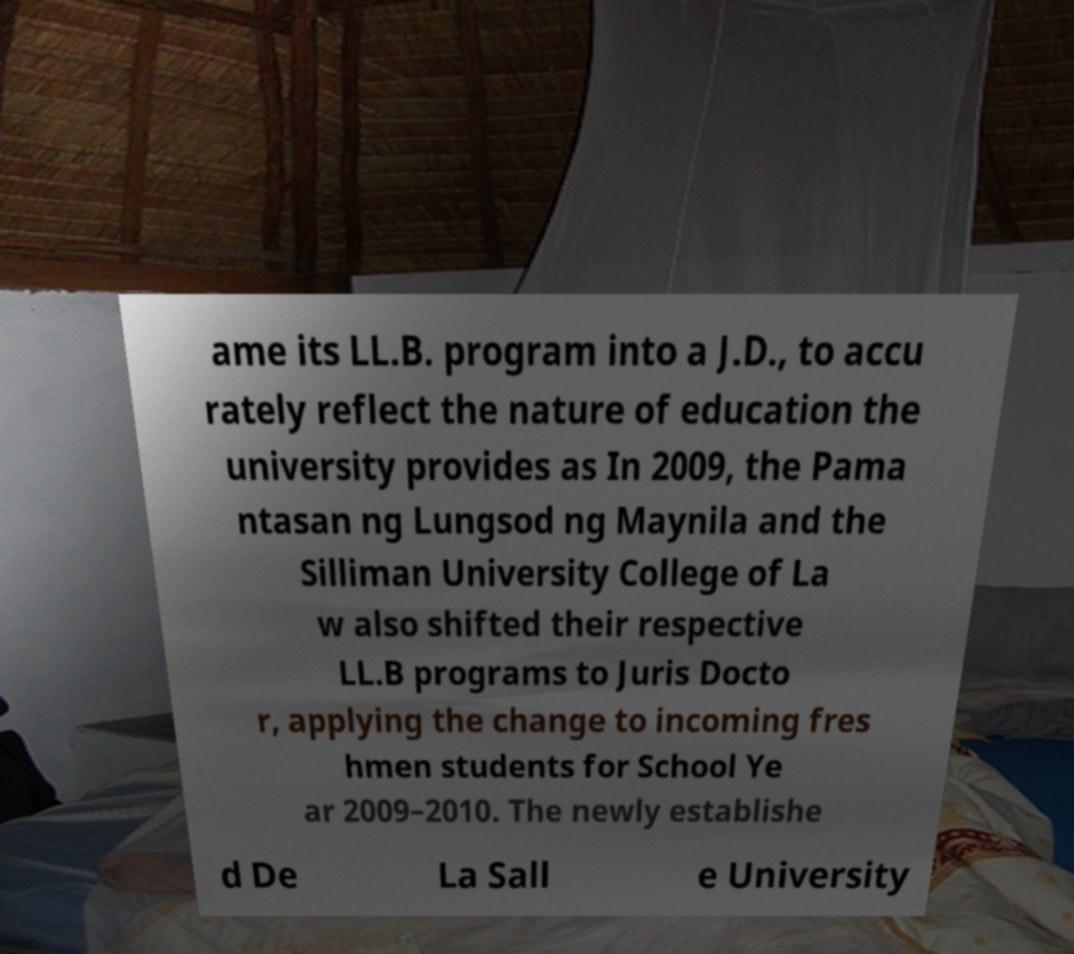There's text embedded in this image that I need extracted. Can you transcribe it verbatim? ame its LL.B. program into a J.D., to accu rately reflect the nature of education the university provides as In 2009, the Pama ntasan ng Lungsod ng Maynila and the Silliman University College of La w also shifted their respective LL.B programs to Juris Docto r, applying the change to incoming fres hmen students for School Ye ar 2009–2010. The newly establishe d De La Sall e University 